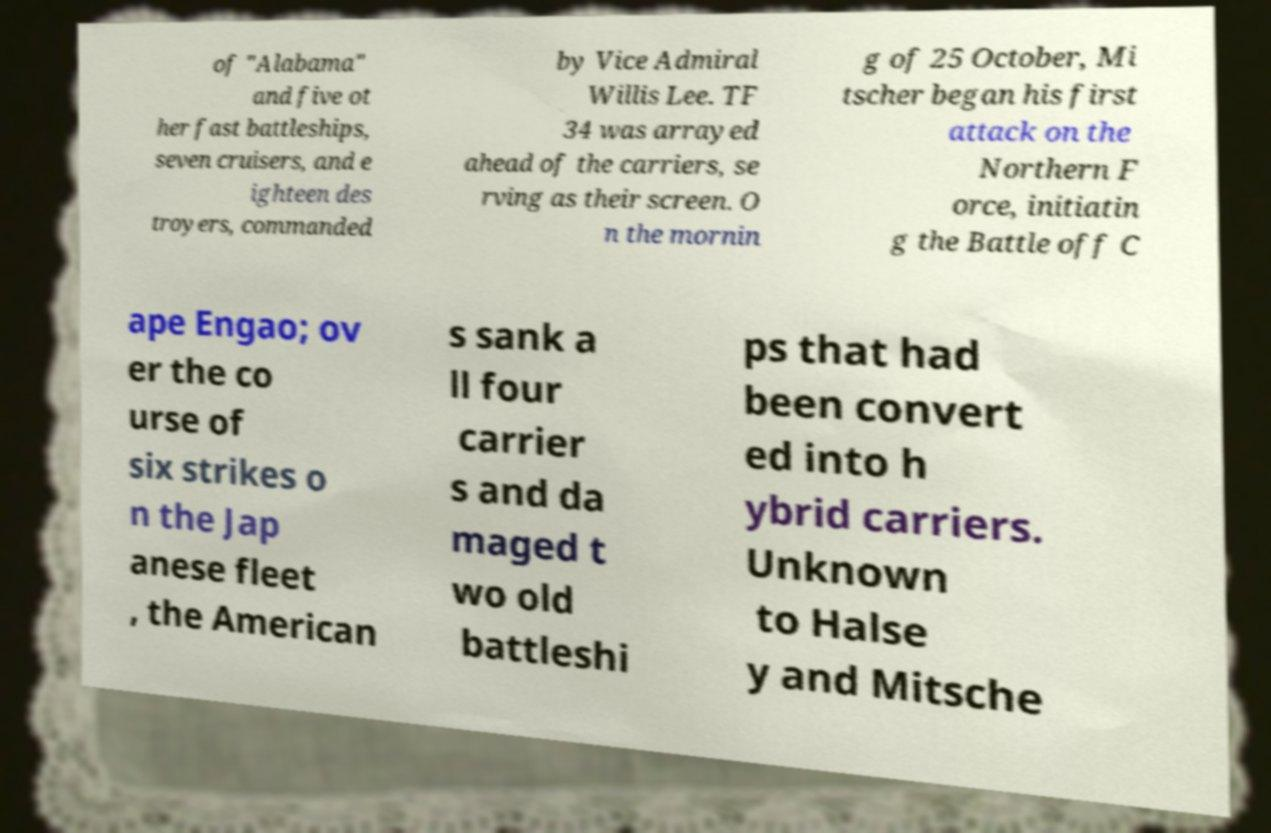Can you read and provide the text displayed in the image?This photo seems to have some interesting text. Can you extract and type it out for me? of "Alabama" and five ot her fast battleships, seven cruisers, and e ighteen des troyers, commanded by Vice Admiral Willis Lee. TF 34 was arrayed ahead of the carriers, se rving as their screen. O n the mornin g of 25 October, Mi tscher began his first attack on the Northern F orce, initiatin g the Battle off C ape Engao; ov er the co urse of six strikes o n the Jap anese fleet , the American s sank a ll four carrier s and da maged t wo old battleshi ps that had been convert ed into h ybrid carriers. Unknown to Halse y and Mitsche 